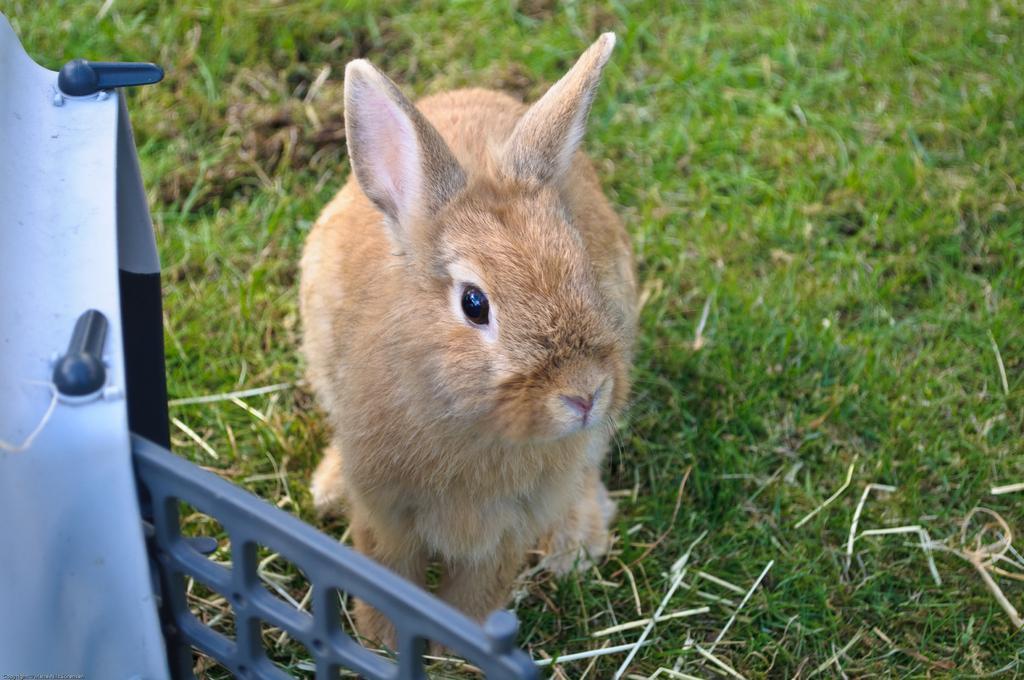Could you give a brief overview of what you see in this image? In the center of the image we can see a rabbit. On the left there is a cage. At the bottom there is grass. 